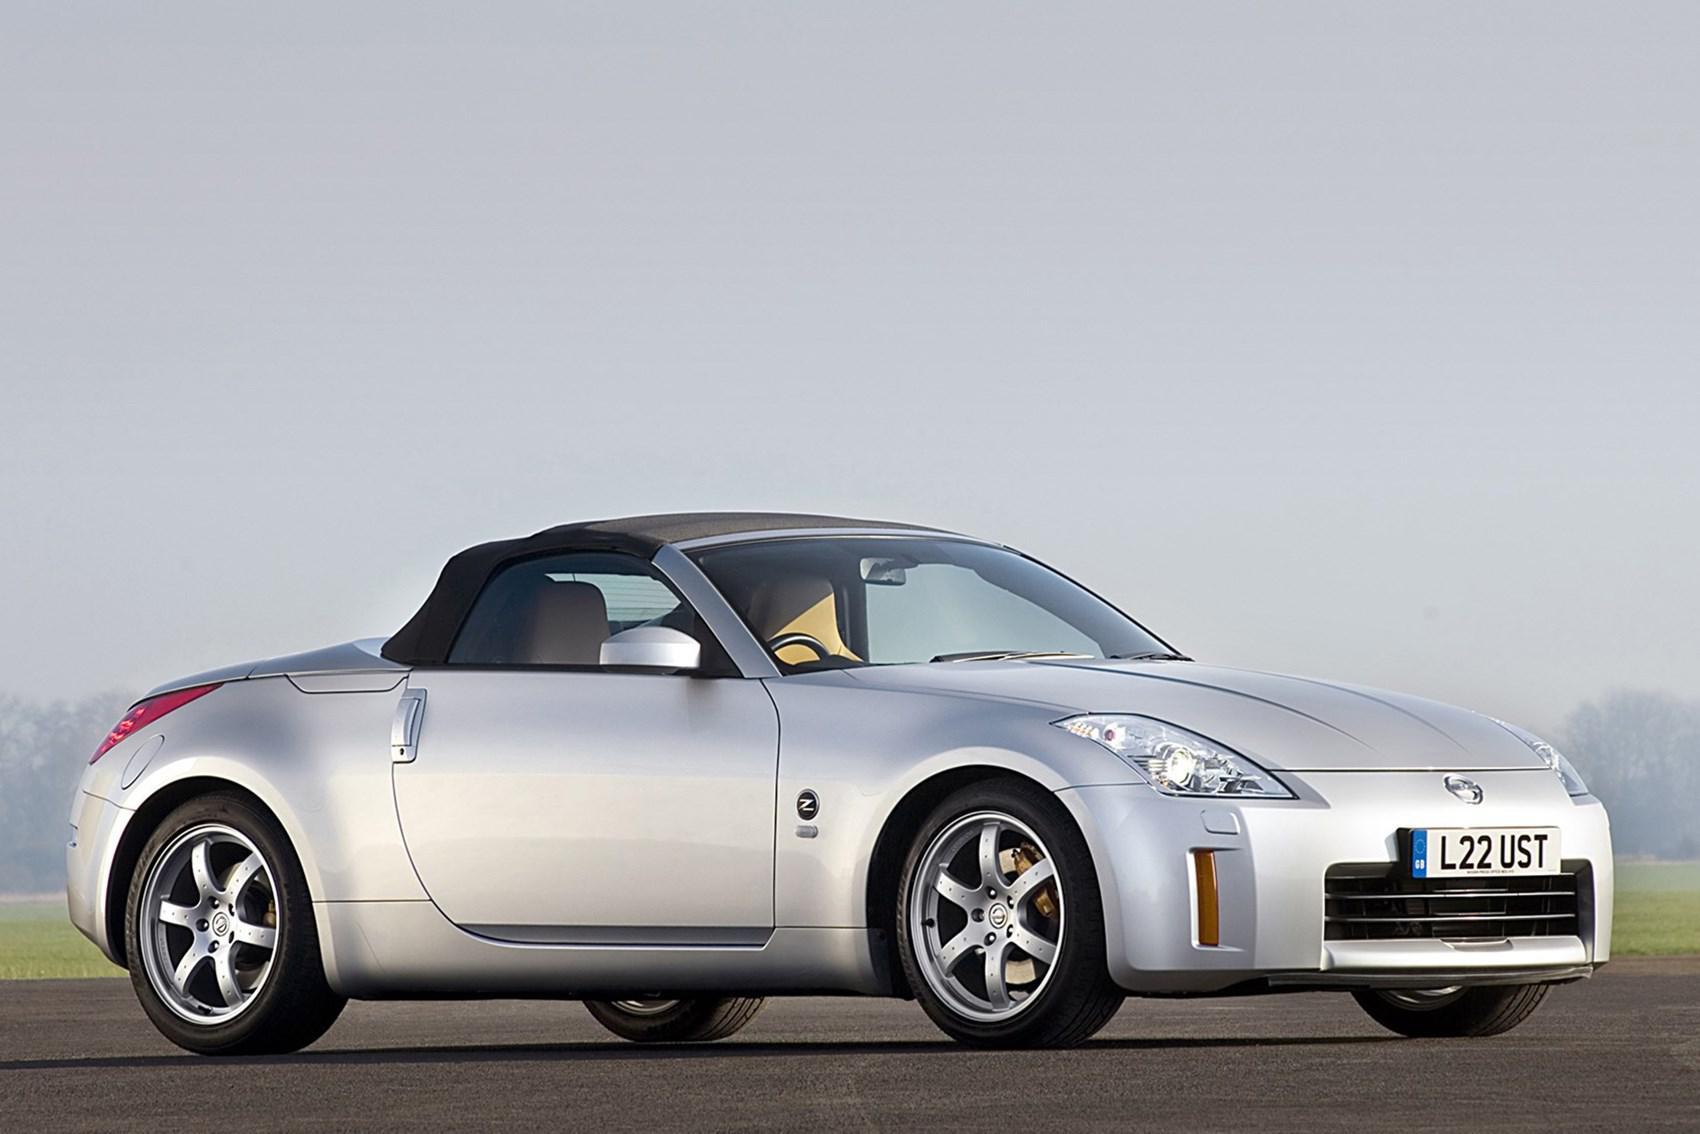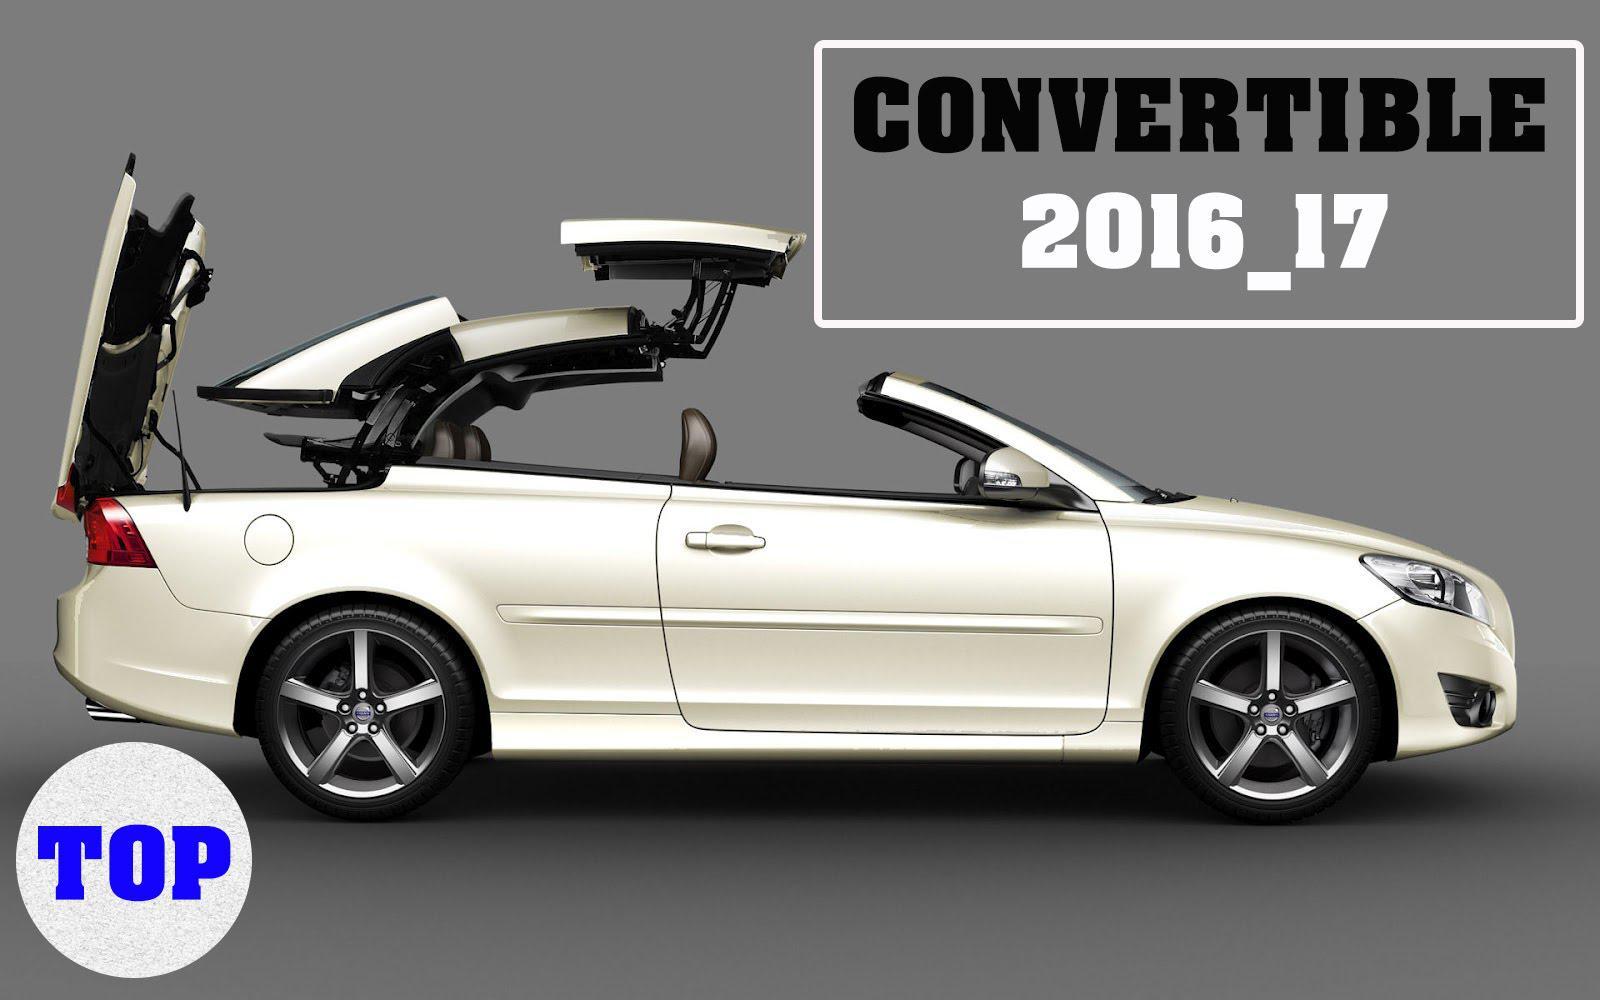The first image is the image on the left, the second image is the image on the right. Analyze the images presented: Is the assertion "Both convertibles have their tops down." valid? Answer yes or no. No. The first image is the image on the left, the second image is the image on the right. Analyze the images presented: Is the assertion "Each image shows a car with its top down, and one image shows someone behind the wheel of a car." valid? Answer yes or no. No. 